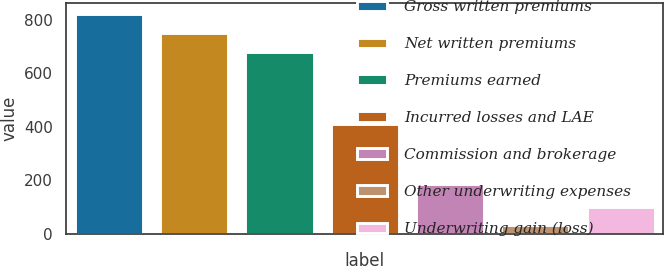Convert chart to OTSL. <chart><loc_0><loc_0><loc_500><loc_500><bar_chart><fcel>Gross written premiums<fcel>Net written premiums<fcel>Premiums earned<fcel>Incurred losses and LAE<fcel>Commission and brokerage<fcel>Other underwriting expenses<fcel>Underwriting gain (loss)<nl><fcel>821.66<fcel>751.28<fcel>680.9<fcel>408.2<fcel>184.4<fcel>30.6<fcel>100.98<nl></chart> 